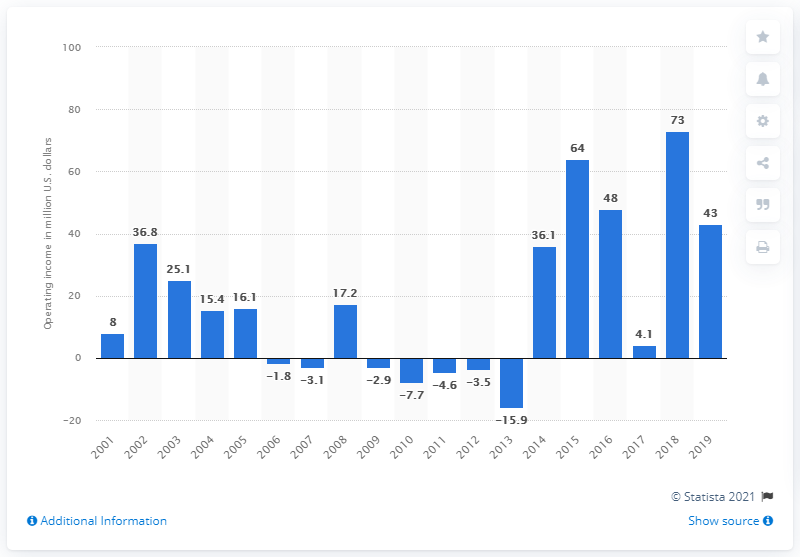Indicate a few pertinent items in this graphic. The Detroit Lions' operating income during the 2019 season was $43 million. 